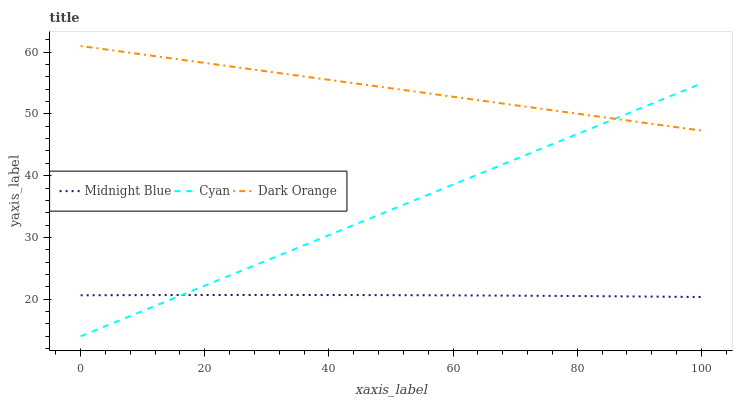Does Midnight Blue have the minimum area under the curve?
Answer yes or no. Yes. Does Dark Orange have the maximum area under the curve?
Answer yes or no. Yes. Does Dark Orange have the minimum area under the curve?
Answer yes or no. No. Does Midnight Blue have the maximum area under the curve?
Answer yes or no. No. Is Cyan the smoothest?
Answer yes or no. Yes. Is Midnight Blue the roughest?
Answer yes or no. Yes. Is Dark Orange the smoothest?
Answer yes or no. No. Is Dark Orange the roughest?
Answer yes or no. No. Does Midnight Blue have the lowest value?
Answer yes or no. No. Does Midnight Blue have the highest value?
Answer yes or no. No. Is Midnight Blue less than Dark Orange?
Answer yes or no. Yes. Is Dark Orange greater than Midnight Blue?
Answer yes or no. Yes. Does Midnight Blue intersect Dark Orange?
Answer yes or no. No. 